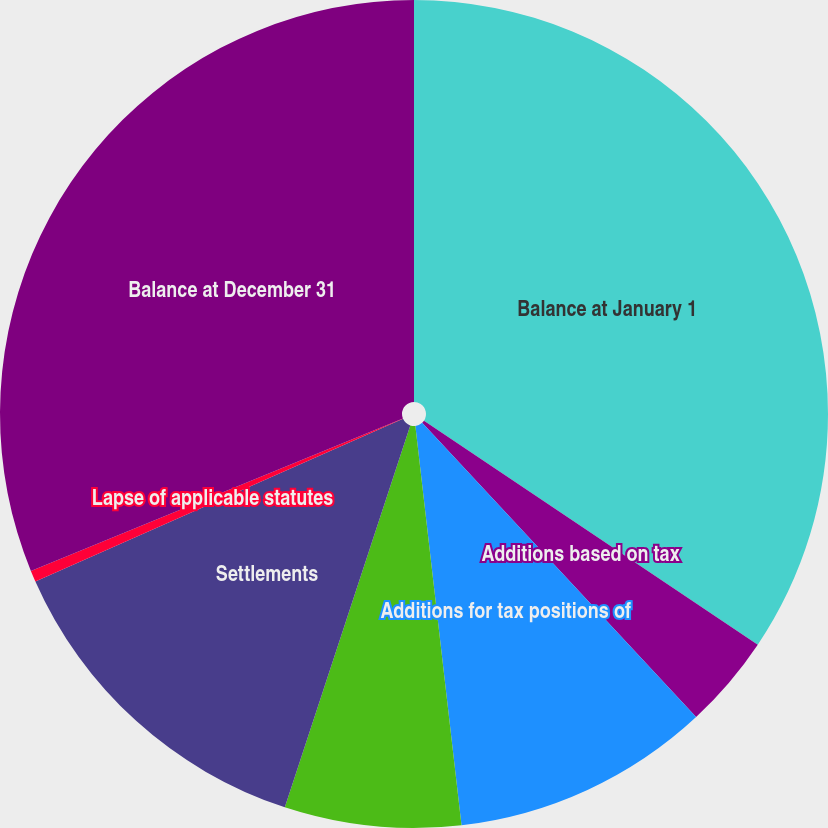Convert chart. <chart><loc_0><loc_0><loc_500><loc_500><pie_chart><fcel>Balance at January 1<fcel>Additions based on tax<fcel>Additions for tax positions of<fcel>Reductions for tax positions<fcel>Settlements<fcel>Lapse of applicable statutes<fcel>Balance at December 31<nl><fcel>34.4%<fcel>3.66%<fcel>10.1%<fcel>6.88%<fcel>13.32%<fcel>0.44%<fcel>31.18%<nl></chart> 